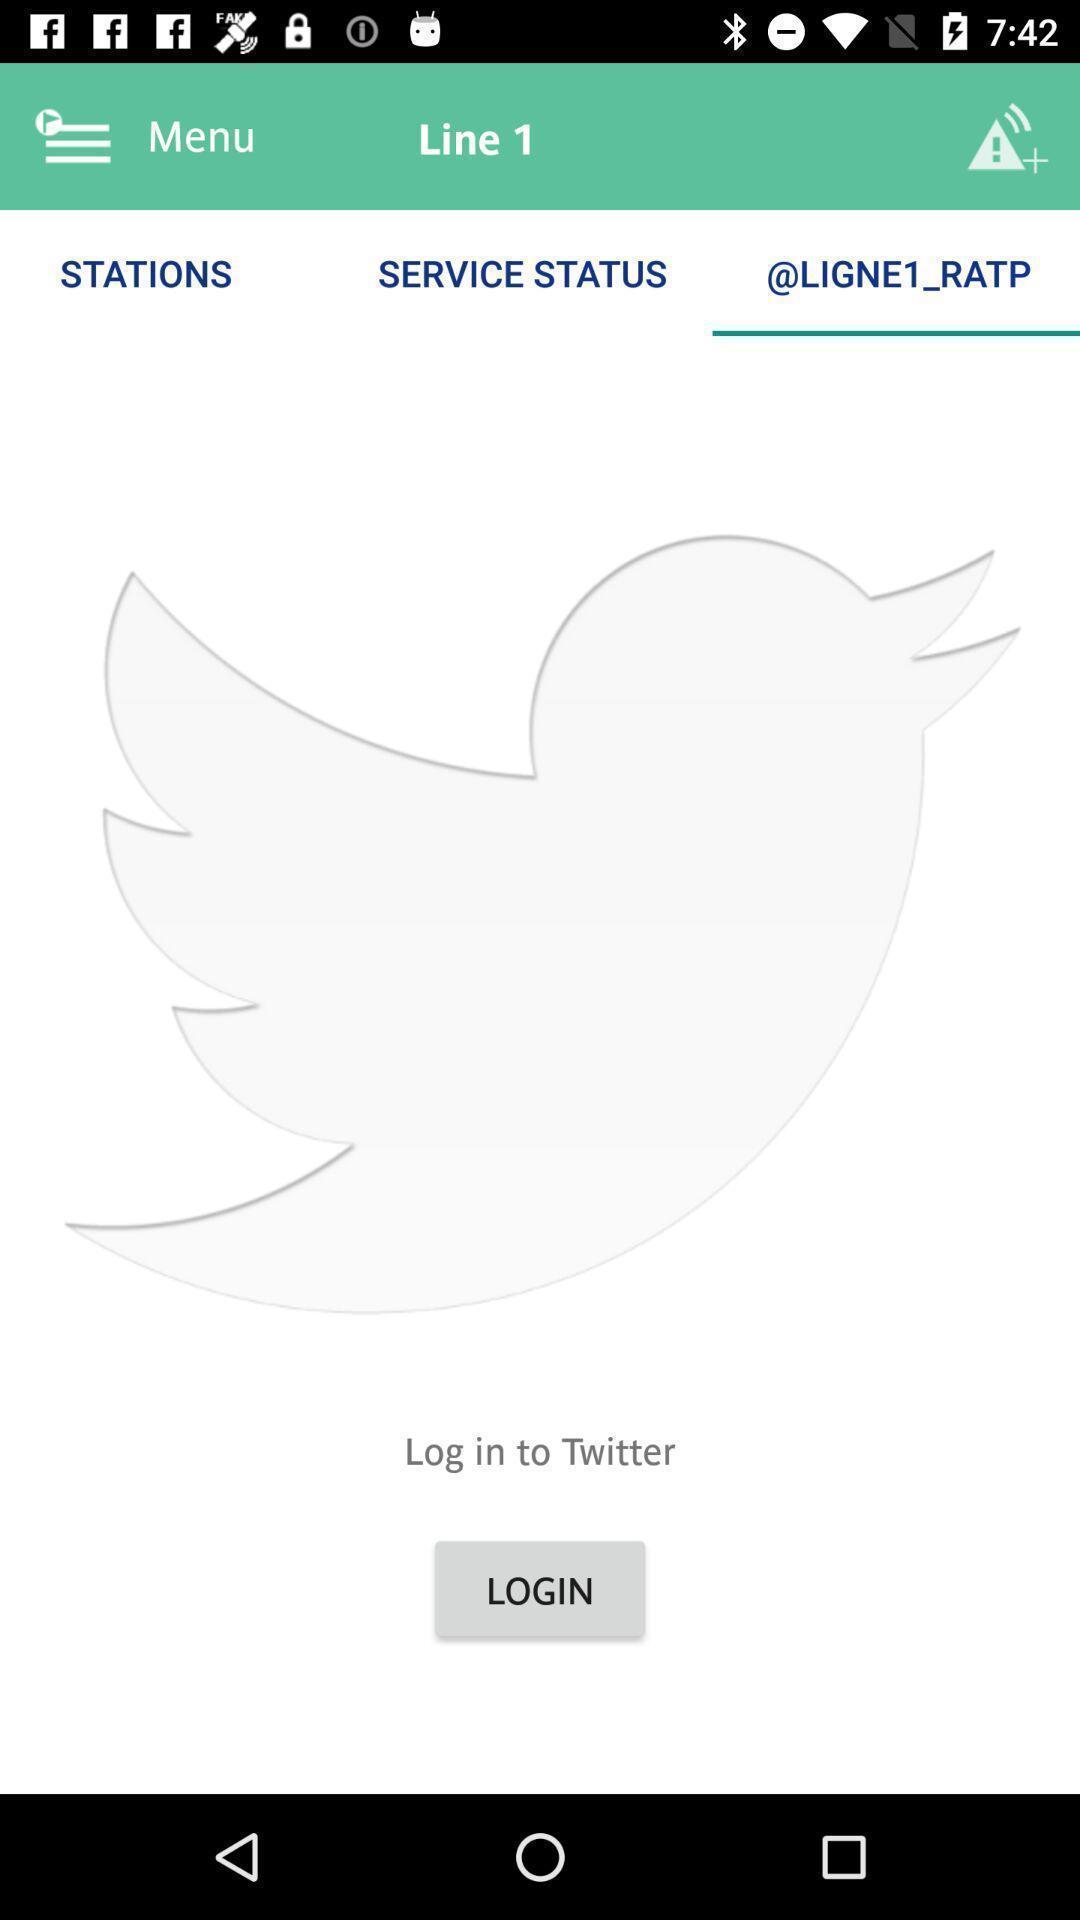Describe the key features of this screenshot. Page displaying empty with many options. 